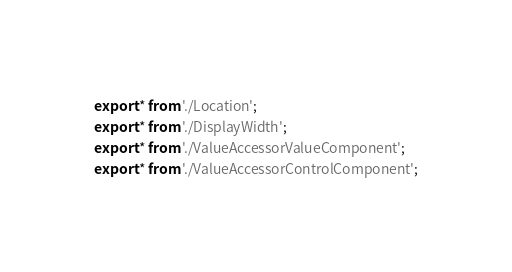Convert code to text. <code><loc_0><loc_0><loc_500><loc_500><_TypeScript_>export * from './Location';
export * from './DisplayWidth';
export * from './ValueAccessorValueComponent';
export * from './ValueAccessorControlComponent';
</code> 